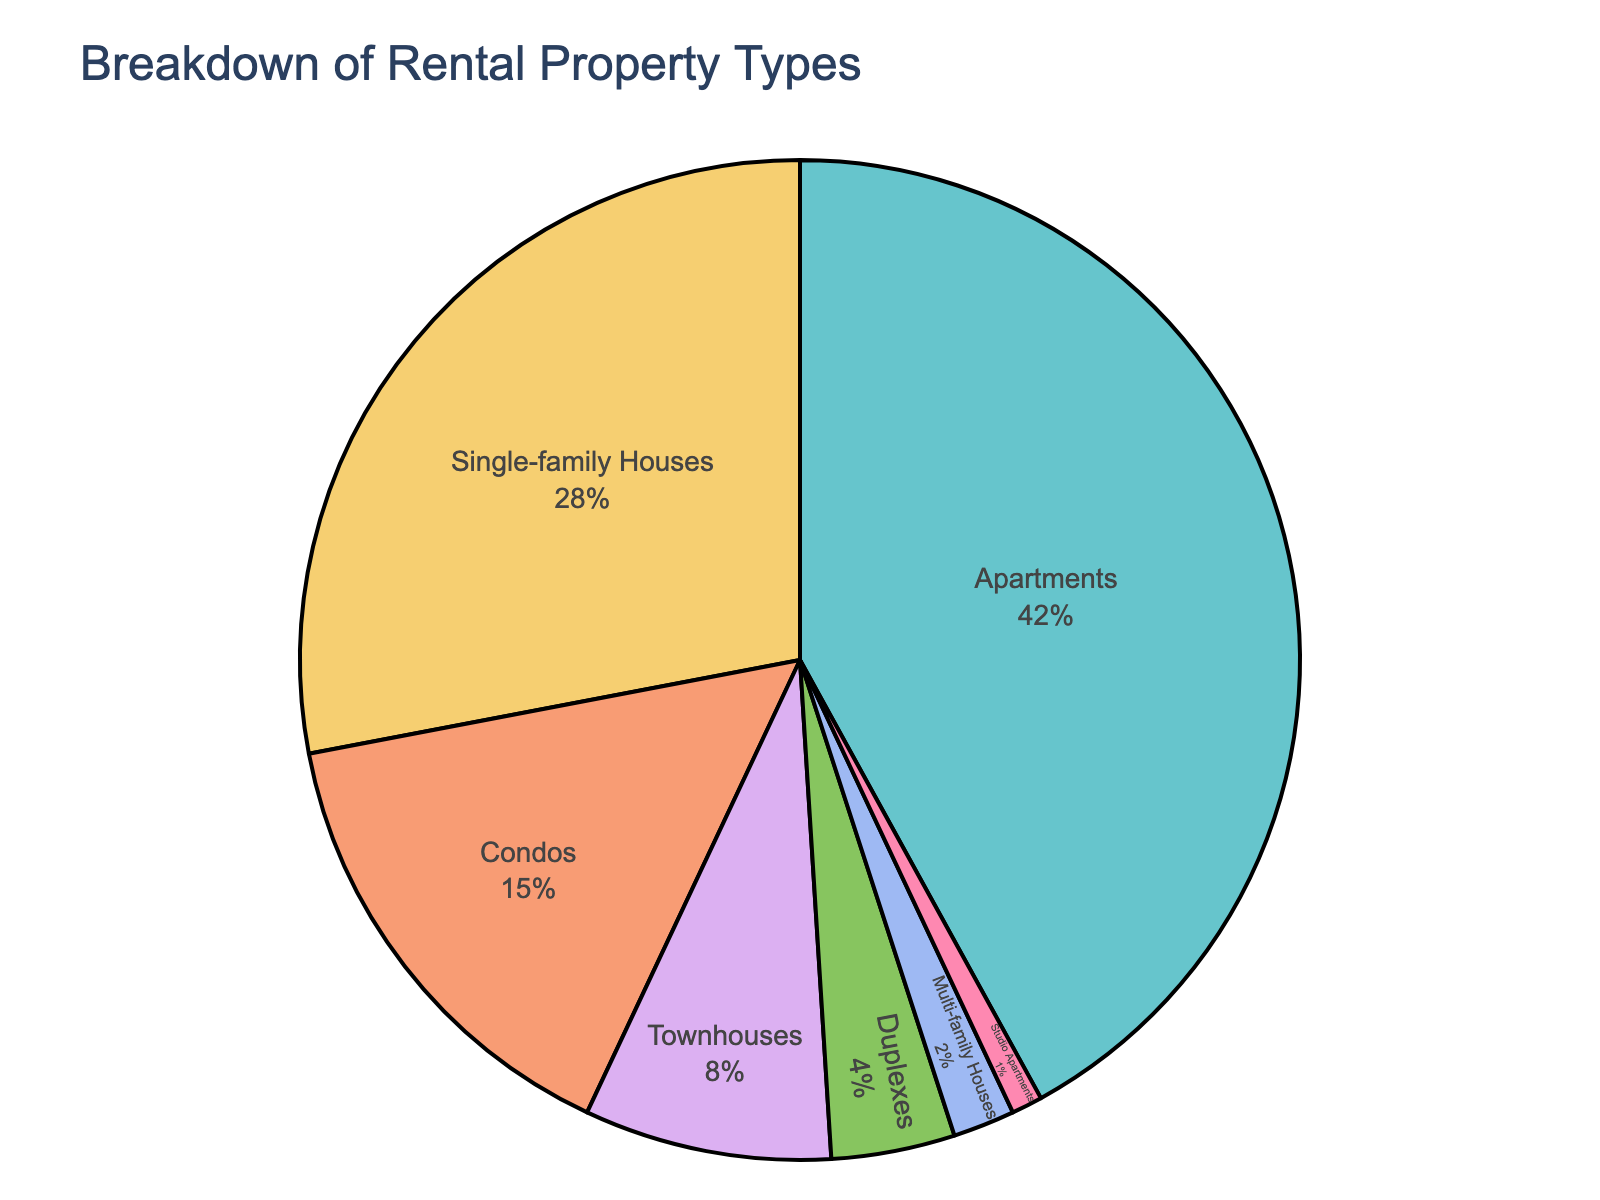What property type has the largest percentage? The pie chart shows different property types with their corresponding percentages. The biggest section of the pie chart, labeled "Apartments," is the largest.
Answer: Apartments What property type has the smallest percentage? The pie chart shows different property types with their corresponding percentages. The smallest section of the pie chart is labeled "Studio Apartments" with 1%.
Answer: Studio Apartments What's the combined percentage of Condos and Townhouses? The pie chart shows Condos with 15% and Townhouses with 8%. Adding these two values, 15% + 8% = 23%.
Answer: 23% Is the percentage of Single-family Houses greater or less than Condos? The pie chart shows Single-family Houses (28%) and Condos (15%). Since 28% is greater than 15%, the percentage of Single-family Houses is greater.
Answer: Greater How much more is the percentage of Apartments compared to Duplexes? The pie chart shows Apartments with 42% and Duplexes with 4%. The difference is 42% - 4% = 38%.
Answer: 38% Which property types together make up more than 50% of the managed properties? The pie chart shows the percentages of different property types. Adding Apartments (42%) and Single-family Houses (28%) gives 42% + 28% = 70%, which is more than 50%.
Answer: Apartments and Single-family Houses What's the average percentage of Townhouses, Duplexes, and Multi-family Houses? The pie chart shows these percentages: Townhouses (8%), Duplexes (4%), and Multi-family Houses (2%). The average is (8% + 4% + 2%) / 3 = 14% / 3 ≈ 4.67%.
Answer: 4.67% What is the total percentage represented by property types with less than 10% each? The pie chart shows percentages for Townhouses (8%), Duplexes (4%), Multi-family Houses (2%), and Studio Apartments (1%). Adding these values, 8% + 4% + 2% + 1% = 15%.
Answer: 15% How many property types have a percentage greater than 10%? The pie chart shows percentages for all property types. Only three have more than 10%: Apartments (42%), Single-family Houses (28%), and Condos (15%).
Answer: 3 